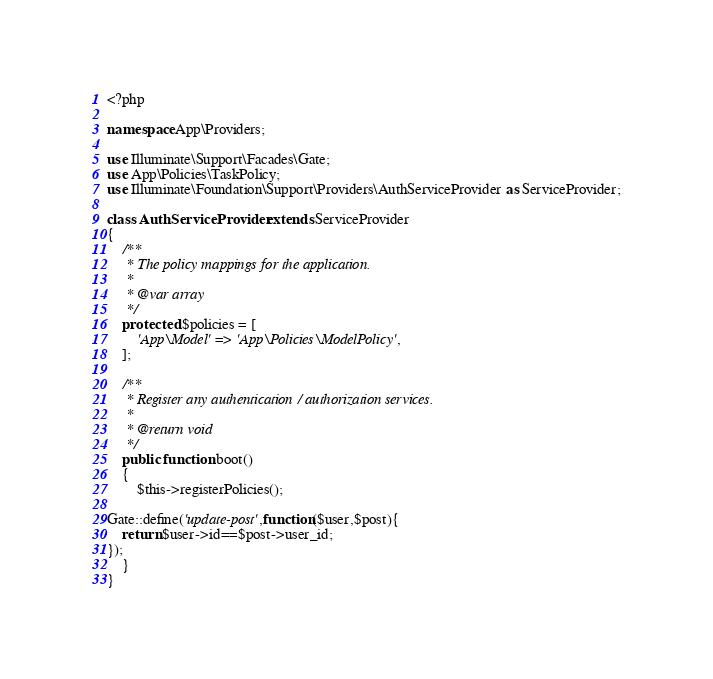Convert code to text. <code><loc_0><loc_0><loc_500><loc_500><_PHP_><?php

namespace App\Providers;

use Illuminate\Support\Facades\Gate;
use App\Policies\TaskPolicy;
use Illuminate\Foundation\Support\Providers\AuthServiceProvider as ServiceProvider;

class AuthServiceProvider extends ServiceProvider
{
    /**
     * The policy mappings for the application.
     *
     * @var array
     */
    protected $policies = [
        'App\Model' => 'App\Policies\ModelPolicy',
    ];

    /**
     * Register any authentication / authorization services.
     *
     * @return void
     */
    public function boot()
    {
        $this->registerPolicies();

Gate::define('update-post',function($user,$post){
    return $user->id==$post->user_id;
});
    }
}
</code> 